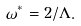Convert formula to latex. <formula><loc_0><loc_0><loc_500><loc_500>\omega ^ { * } = 2 / \Lambda .</formula> 